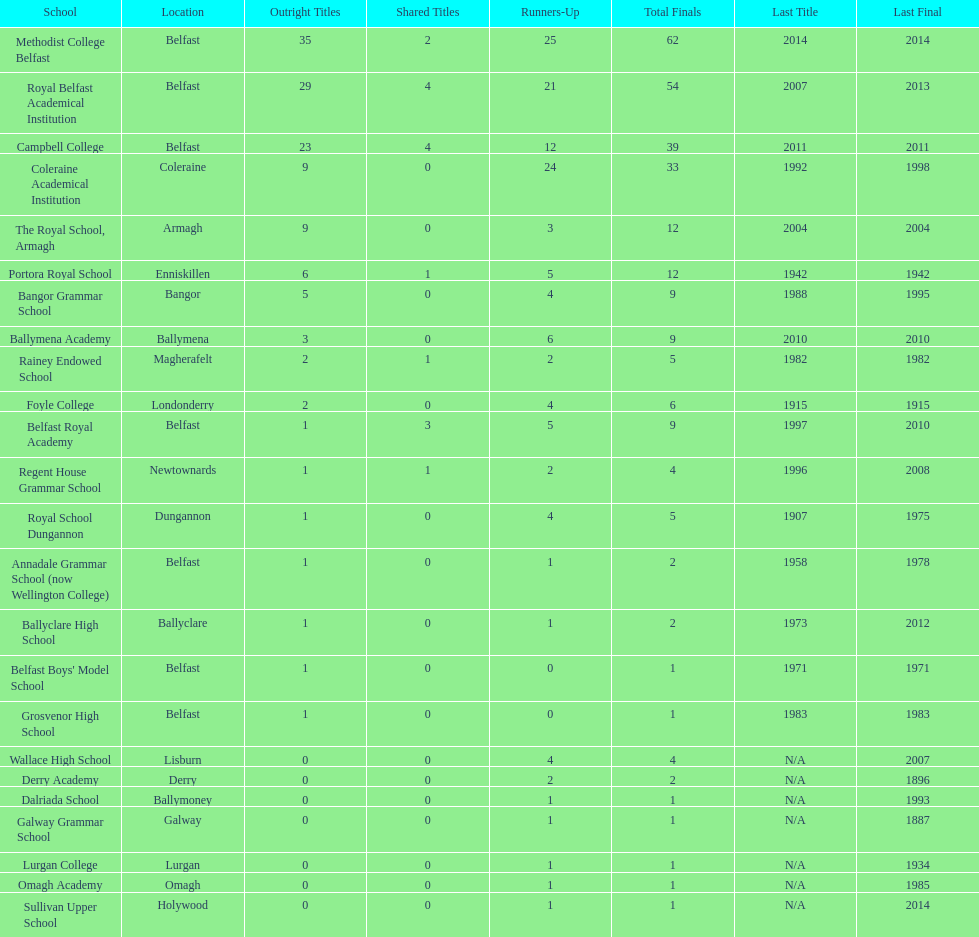What number of total finals does foyle college have? 6. 